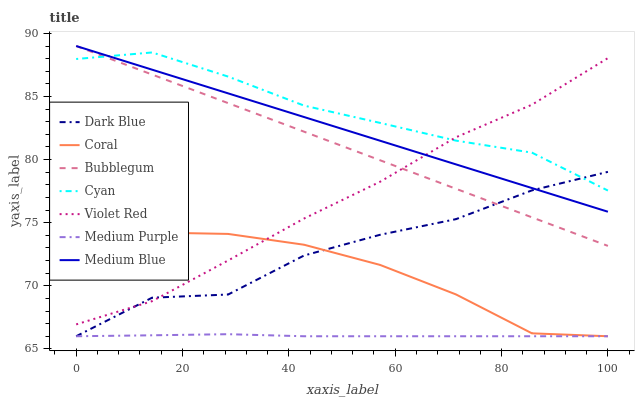Does Coral have the minimum area under the curve?
Answer yes or no. No. Does Coral have the maximum area under the curve?
Answer yes or no. No. Is Coral the smoothest?
Answer yes or no. No. Is Coral the roughest?
Answer yes or no. No. Does Medium Blue have the lowest value?
Answer yes or no. No. Does Coral have the highest value?
Answer yes or no. No. Is Medium Purple less than Medium Blue?
Answer yes or no. Yes. Is Cyan greater than Medium Purple?
Answer yes or no. Yes. Does Medium Purple intersect Medium Blue?
Answer yes or no. No. 